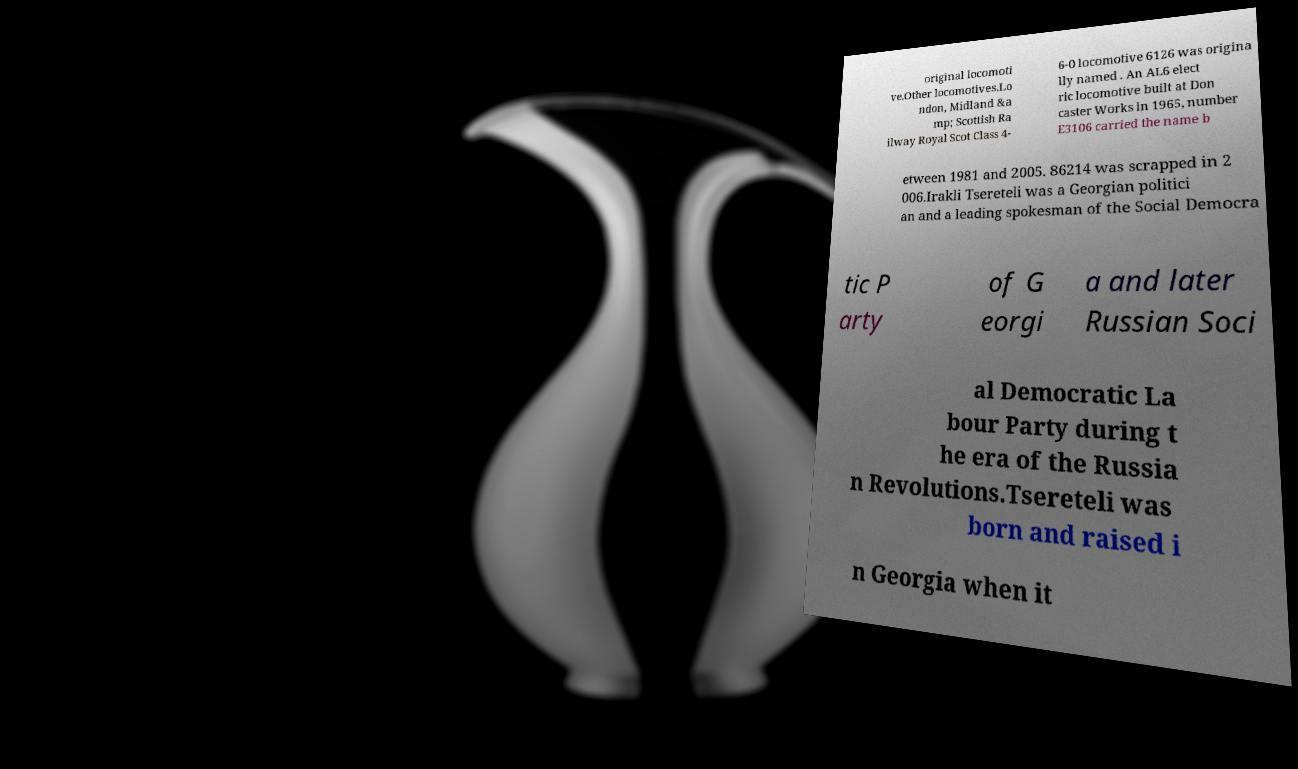Could you extract and type out the text from this image? original locomoti ve.Other locomotives.Lo ndon, Midland &a mp; Scottish Ra ilway Royal Scot Class 4- 6-0 locomotive 6126 was origina lly named . An AL6 elect ric locomotive built at Don caster Works in 1965, number E3106 carried the name b etween 1981 and 2005. 86214 was scrapped in 2 006.Irakli Tsereteli was a Georgian politici an and a leading spokesman of the Social Democra tic P arty of G eorgi a and later Russian Soci al Democratic La bour Party during t he era of the Russia n Revolutions.Tsereteli was born and raised i n Georgia when it 